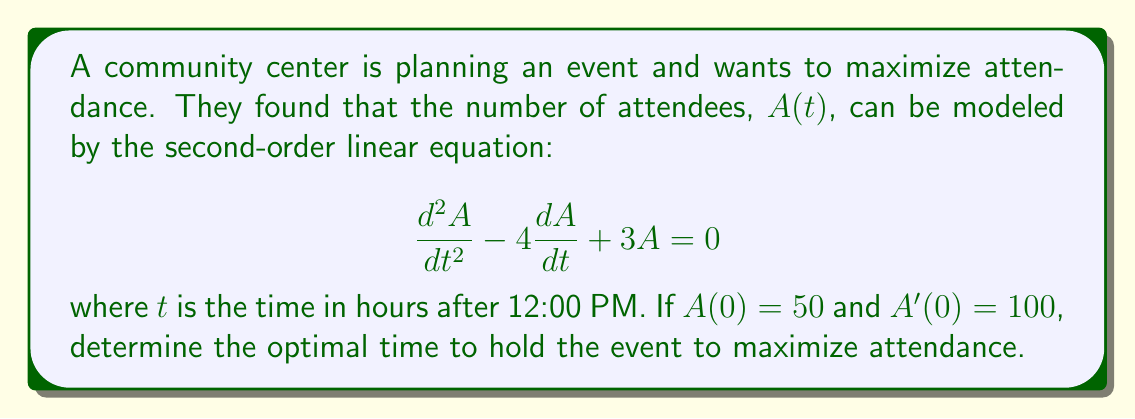Can you solve this math problem? To solve this problem, we need to follow these steps:

1) First, we need to solve the characteristic equation:
   $$r^2 - 4r + 3 = 0$$
   Using the quadratic formula, we get:
   $$r = \frac{4 \pm \sqrt{16 - 12}}{2} = \frac{4 \pm 2}{2}$$
   So, $r_1 = 3$ and $r_2 = 1$

2) The general solution is:
   $$A(t) = c_1e^{3t} + c_2e^t$$

3) To find $c_1$ and $c_2$, we use the initial conditions:
   $A(0) = 50$: $c_1 + c_2 = 50$
   $A'(0) = 100$: $3c_1 + c_2 = 100$

4) Solving these equations:
   $c_2 = 50 - c_1$
   $3c_1 + (50 - c_1) = 100$
   $2c_1 = 50$
   $c_1 = 25$, and consequently, $c_2 = 25$

5) Therefore, the specific solution is:
   $$A(t) = 25e^{3t} + 25e^t$$

6) To find the maximum, we differentiate and set to zero:
   $$A'(t) = 75e^{3t} + 25e^t$$
   $$A''(t) = 225e^{3t} + 25e^t$$

   Set $A'(t) = 0$:
   $$75e^{3t} + 25e^t = 0$$
   $$25e^t(3e^{2t} + 1) = 0$$
   $$e^{2t} = -\frac{1}{3}$$
   $$t = \frac{1}{2}\ln(\frac{1}{3}) \approx 0.549$$

7) To confirm this is a maximum, we check $A''(t)$ at this point:
   $A''(0.549) \approx -41.9 < 0$, confirming a maximum.
Answer: The optimal time to hold the event is approximately 0.549 hours (about 33 minutes) after 12:00 PM, or around 12:33 PM. 